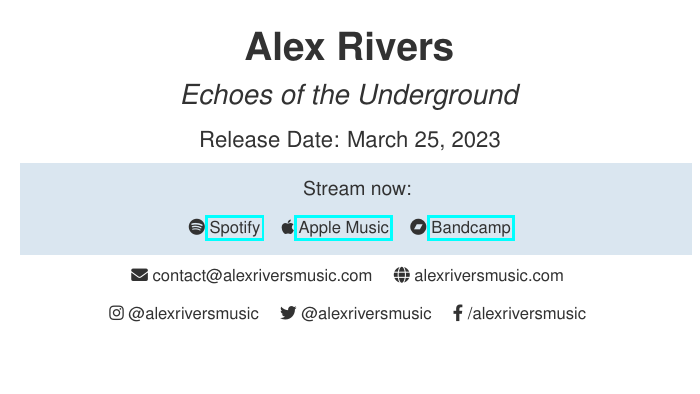What is the name of the artist? The name of the artist is prominently displayed at the top of the business card.
Answer: Alex Rivers What is the title of the latest album? The album title is listed right below the artist's name on the card.
Answer: Echoes of the Underground What is the release date of the album? The release date is mentioned clearly on the card in a designated section.
Answer: March 25, 2023 Which streaming service is first listed? The first streaming service mentioned in the document is found in the section dedicated to streaming.
Answer: Spotify What color is used for the album's background? The document features a specific color for the album's background indicated in the color box.
Answer: RGB(70,130,180) How can you contact Alex Rivers? The contact method is described with a specific label in the document.
Answer: contact@alexriversmusic.com What social media platforms are included? The document lists the social media platforms at the bottom of the card.
Answer: Instagram, Twitter, Facebook How many streaming services are provided? The total number of streaming services is indicated in the streaming section of the card.
Answer: Three 